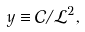<formula> <loc_0><loc_0><loc_500><loc_500>y \equiv \mathcal { C } / \mathcal { L } ^ { 2 } ,</formula> 